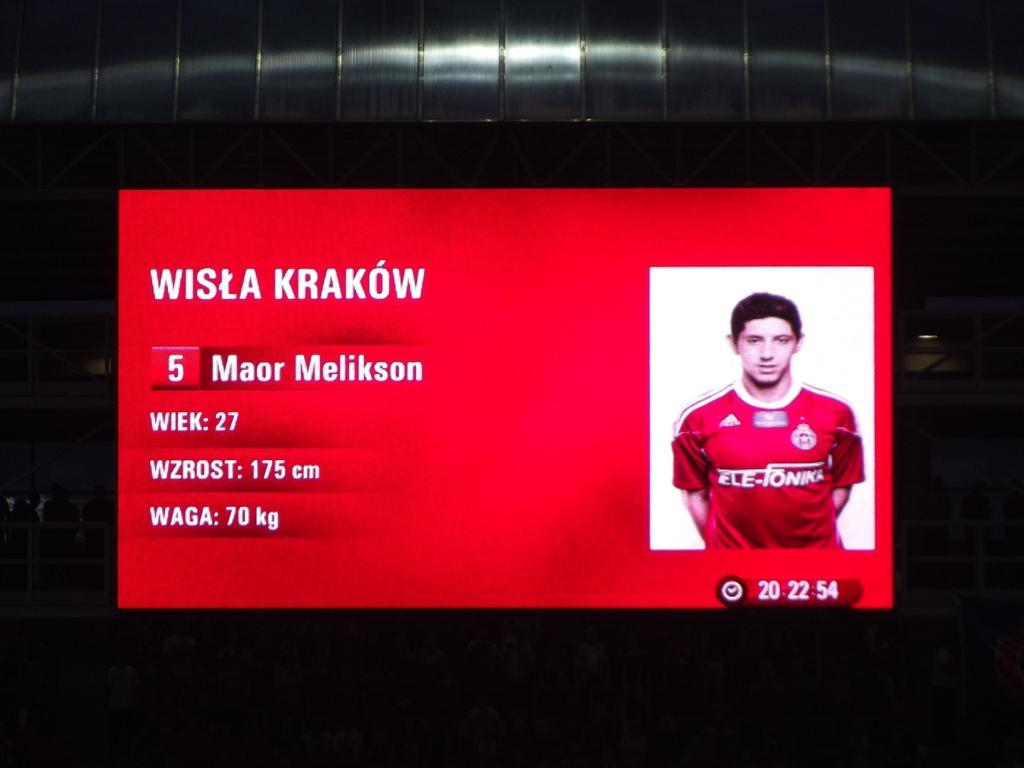<image>
Relay a brief, clear account of the picture shown. A player card of an athlete names Wisla Krakow. 